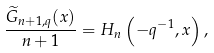Convert formula to latex. <formula><loc_0><loc_0><loc_500><loc_500>\frac { \widetilde { G } _ { n + 1 , q } ( x ) } { n + 1 } = H _ { n } \left ( - q ^ { - 1 } , x \right ) ,</formula> 